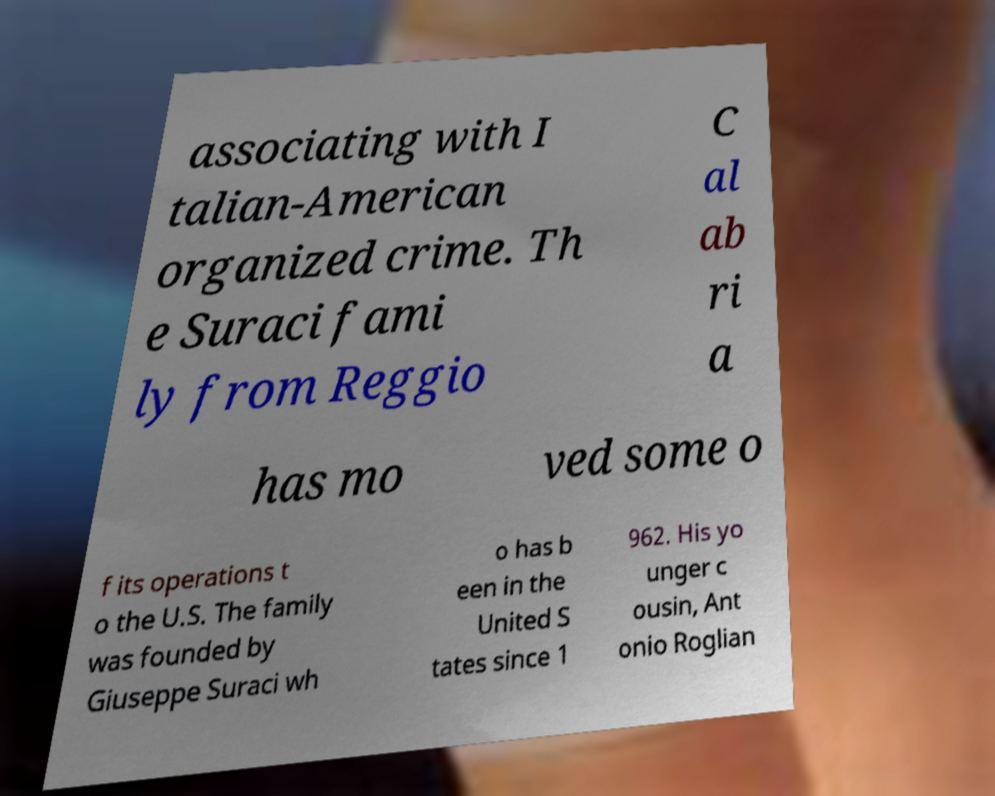Please read and relay the text visible in this image. What does it say? associating with I talian-American organized crime. Th e Suraci fami ly from Reggio C al ab ri a has mo ved some o f its operations t o the U.S. The family was founded by Giuseppe Suraci wh o has b een in the United S tates since 1 962. His yo unger c ousin, Ant onio Roglian 